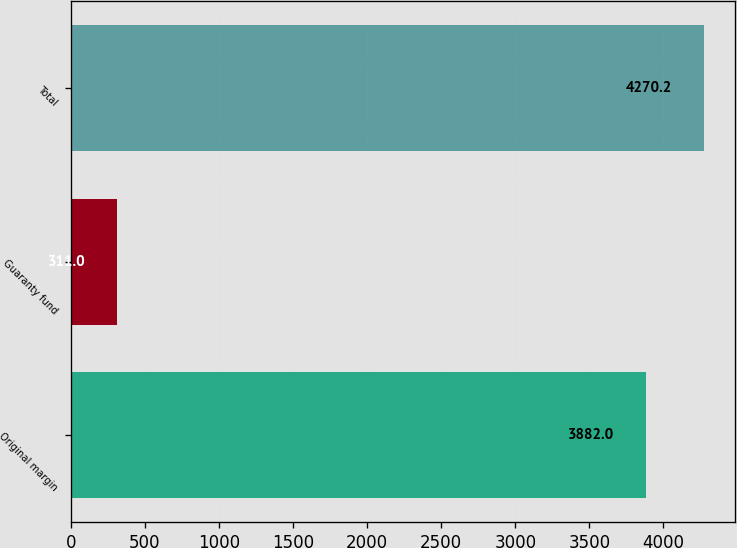Convert chart to OTSL. <chart><loc_0><loc_0><loc_500><loc_500><bar_chart><fcel>Original margin<fcel>Guaranty fund<fcel>Total<nl><fcel>3882<fcel>311<fcel>4270.2<nl></chart> 